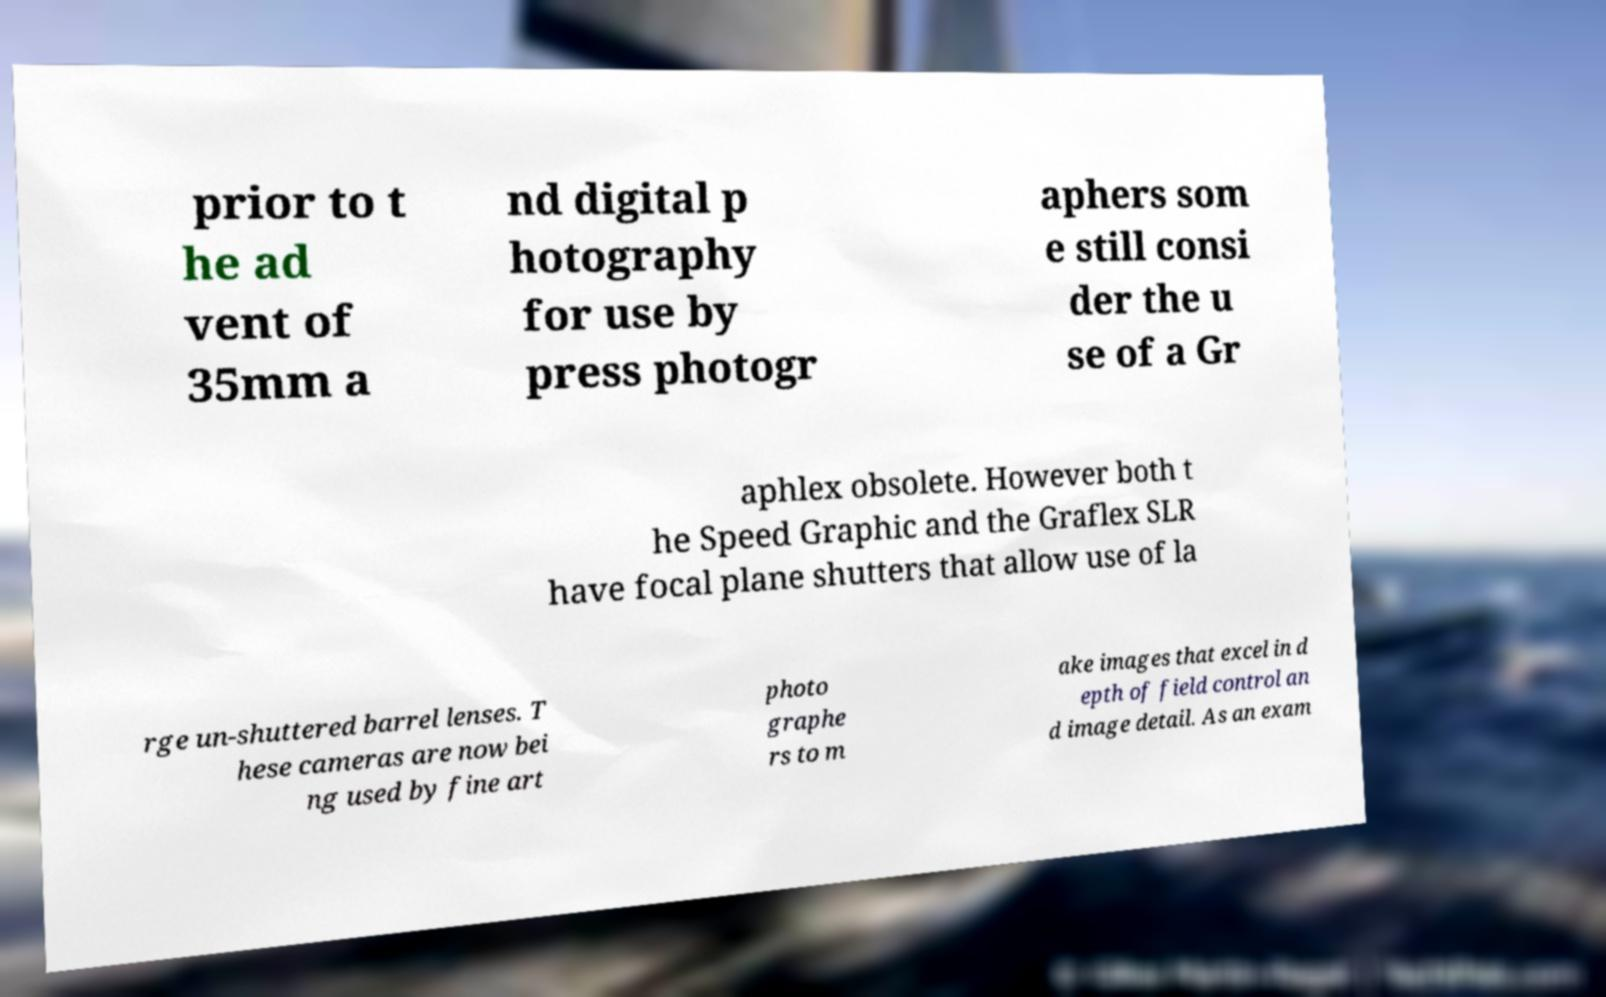Can you read and provide the text displayed in the image?This photo seems to have some interesting text. Can you extract and type it out for me? prior to t he ad vent of 35mm a nd digital p hotography for use by press photogr aphers som e still consi der the u se of a Gr aphlex obsolete. However both t he Speed Graphic and the Graflex SLR have focal plane shutters that allow use of la rge un-shuttered barrel lenses. T hese cameras are now bei ng used by fine art photo graphe rs to m ake images that excel in d epth of field control an d image detail. As an exam 